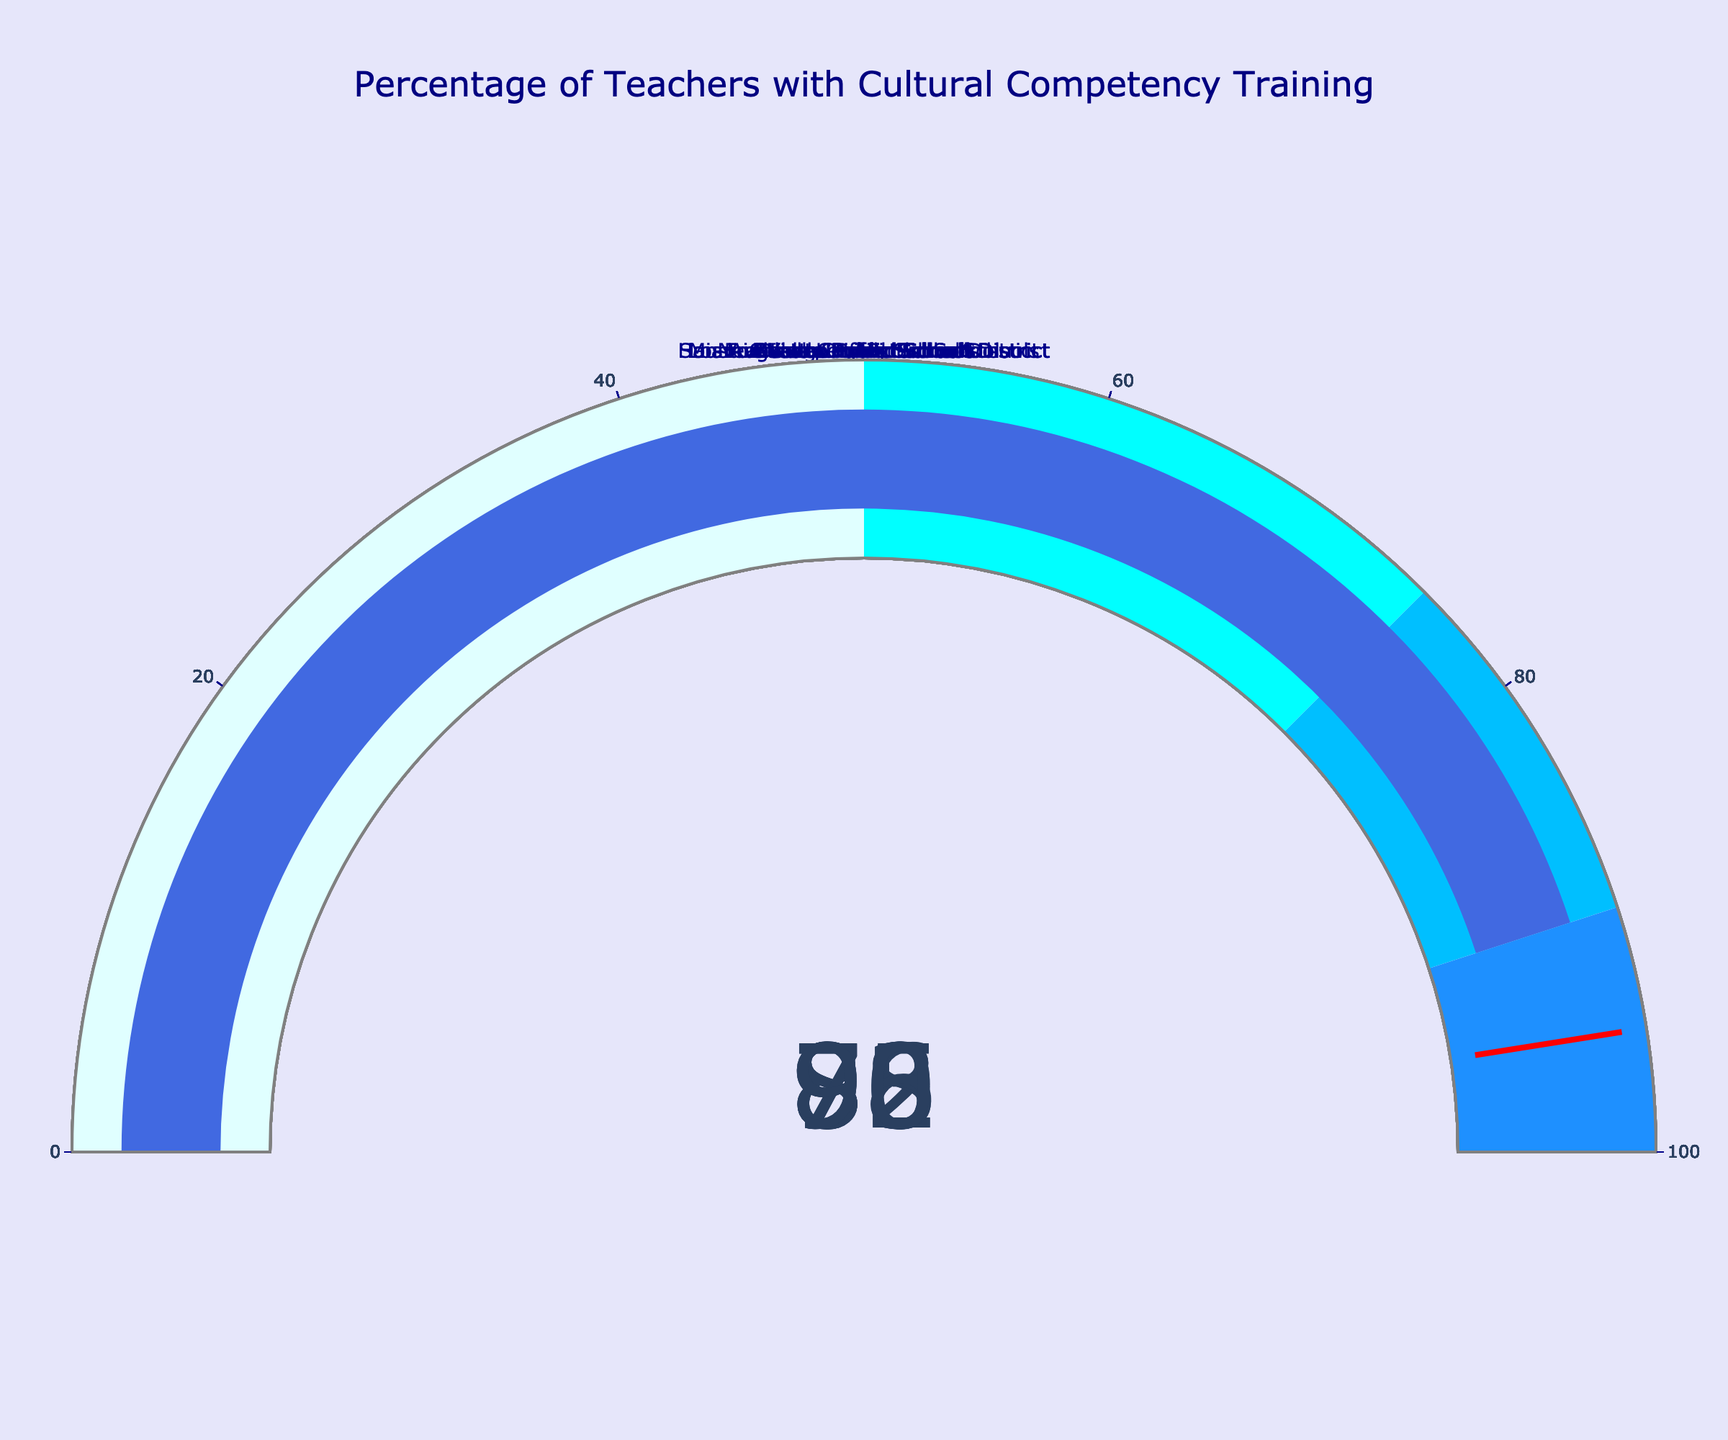What is the title of the figure? The title of the figure is placed at the top, which is typically standard for figures. It reads "Percentage of Teachers with Cultural Competency Training" in navy blue font.
Answer: Percentage of Teachers with Cultural Competency Training Which school district has the lowest percentage of teachers who have received cultural competency training? By examining the gauge charts, we can compare the percentages directly. The school district with the lowest percentage is Chicago Public Schools at 72%.
Answer: Chicago Public Schools What is the average percentage of teachers with cultural competency training across all school districts? To find the average, add all the percentages together and divide by the number of school districts. The percentages are: 78, 85, 72, 92, 80, 88, 95, 83, 76, 90. The sum is 839. Divide 839 by 10 to get the average percentage.
Answer: 83.9 Which school districts have a percentage of trained teachers that falls between 75% and 85%? By looking at each of the gauge charts, we can identify the school districts within this range. These districts are New York City Public Schools (78), Houston Independent School District (80), and Denver Public Schools (76).
Answer: New York City Public Schools, Houston Independent School District, Denver Public Schools How many school districts have at least 90% of their teachers trained in cultural competency? We count the districts where the gauge shows a percentage of 90 or higher. The districts are Miami-Dade County Public Schools (92), San Francisco Unified School District (95), and Seattle Public Schools (90).
Answer: 3 What is the difference in the percentage of trained teachers between the highest and the lowest school districts? Find the highest percentage, which is San Francisco Unified School District at 95%, and the lowest, which is Chicago Public Schools at 72%. Subtract the lowest from the highest: 95 - 72 = 23.
Answer: 23 Which school district has the percentage of trained teachers closest to the overall average? The overall average percentage is 83.9. The provided data percentages closest to the average 83.9 are Boston Public Schools at 88 and Atlanta Public Schools at 83. By comparison, Atlanta Public Schools with 83 is closest.
Answer: Atlanta Public Schools Which school district has a percentage of trained teachers just below 80%? By closely examining the gauge charts, Denver Public Schools has a percentage of trained teachers slightly below 80%, specifically at 76%.
Answer: Denver Public Schools 